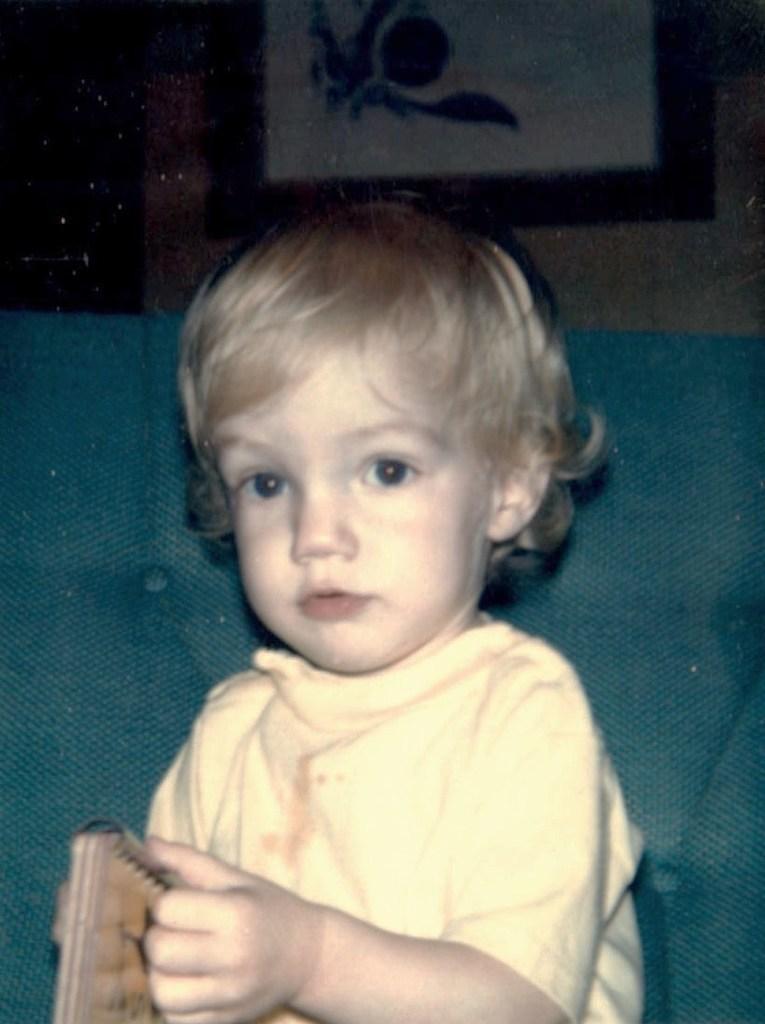Can you describe this image briefly? A little cute baby is sitting, this baby wore a yellow color t-shirt. 